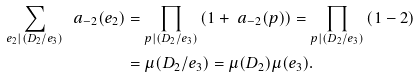Convert formula to latex. <formula><loc_0><loc_0><loc_500><loc_500>\sum _ { e _ { 2 } | ( D _ { 2 } / e _ { 3 } ) } \ a _ { - 2 } ( e _ { 2 } ) & = \prod _ { p | ( D _ { 2 } / e _ { 3 } ) } \left ( 1 + \ a _ { - 2 } ( p ) \right ) = \prod _ { p | ( D _ { 2 } / e _ { 3 } ) } \left ( 1 - 2 \right ) \\ & = \mu ( D _ { 2 } / e _ { 3 } ) = \mu ( D _ { 2 } ) \mu ( e _ { 3 } ) .</formula> 